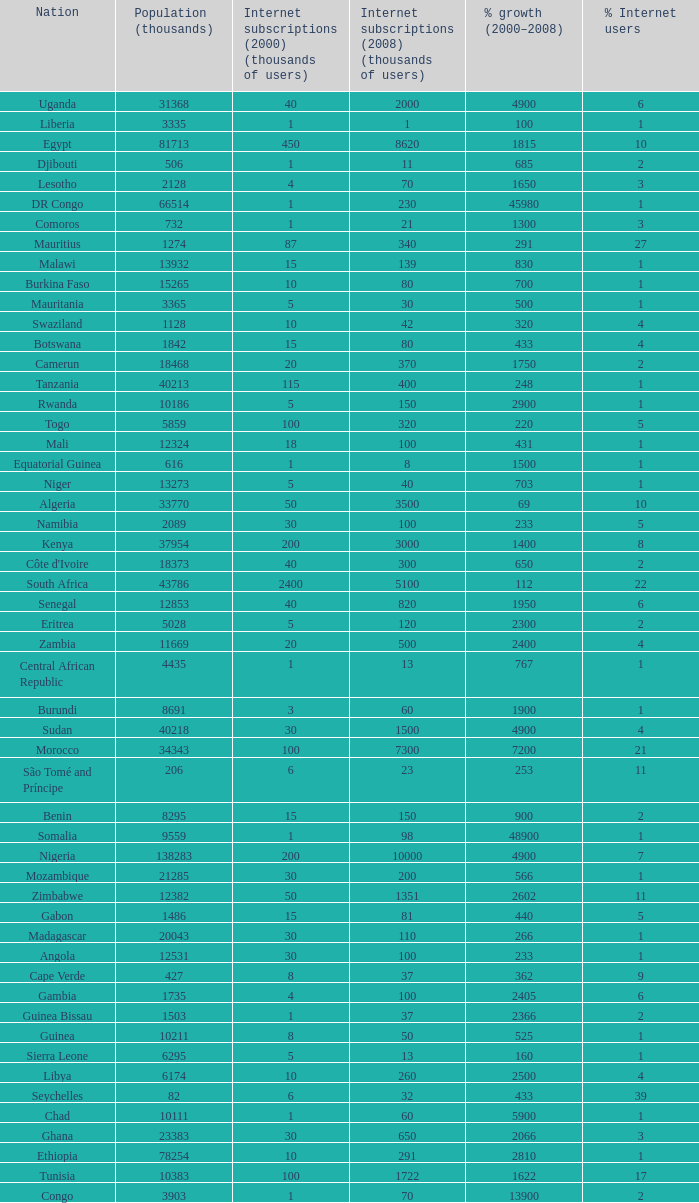What is the percentage of growth in 2000-2008 in ethiopia? 2810.0. 